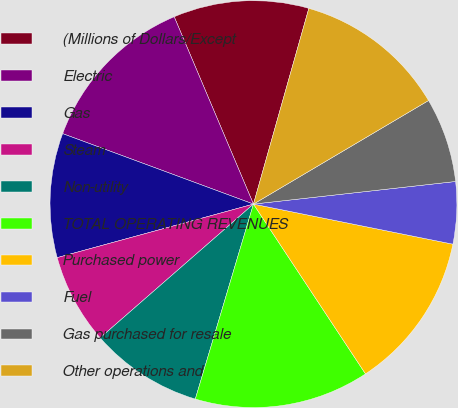<chart> <loc_0><loc_0><loc_500><loc_500><pie_chart><fcel>(Millions of Dollars/Except<fcel>Electric<fcel>Gas<fcel>Steam<fcel>Non-utility<fcel>TOTAL OPERATING REVENUES<fcel>Purchased power<fcel>Fuel<fcel>Gas purchased for resale<fcel>Other operations and<nl><fcel>10.76%<fcel>13.0%<fcel>9.87%<fcel>7.18%<fcel>8.97%<fcel>13.9%<fcel>12.56%<fcel>4.93%<fcel>6.73%<fcel>12.11%<nl></chart> 